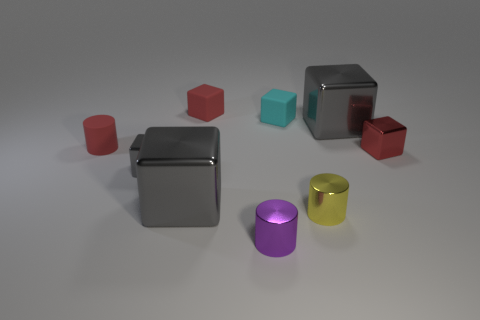Subtract all small gray cubes. How many cubes are left? 5 Subtract all red blocks. How many blocks are left? 4 Subtract 1 cylinders. How many cylinders are left? 2 Add 1 spheres. How many objects exist? 10 Subtract all cylinders. How many objects are left? 6 Add 5 tiny shiny things. How many tiny shiny things exist? 9 Subtract 0 brown cylinders. How many objects are left? 9 Subtract all green cylinders. Subtract all gray cubes. How many cylinders are left? 3 Subtract all yellow spheres. How many red cubes are left? 2 Subtract all tiny cyan rubber cubes. Subtract all blue blocks. How many objects are left? 8 